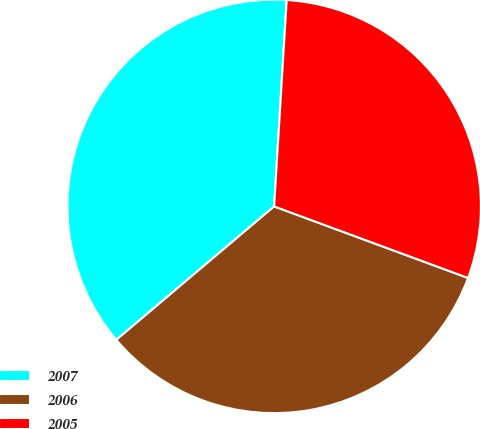Convert chart. <chart><loc_0><loc_0><loc_500><loc_500><pie_chart><fcel>2007<fcel>2006<fcel>2005<nl><fcel>37.14%<fcel>33.2%<fcel>29.66%<nl></chart> 